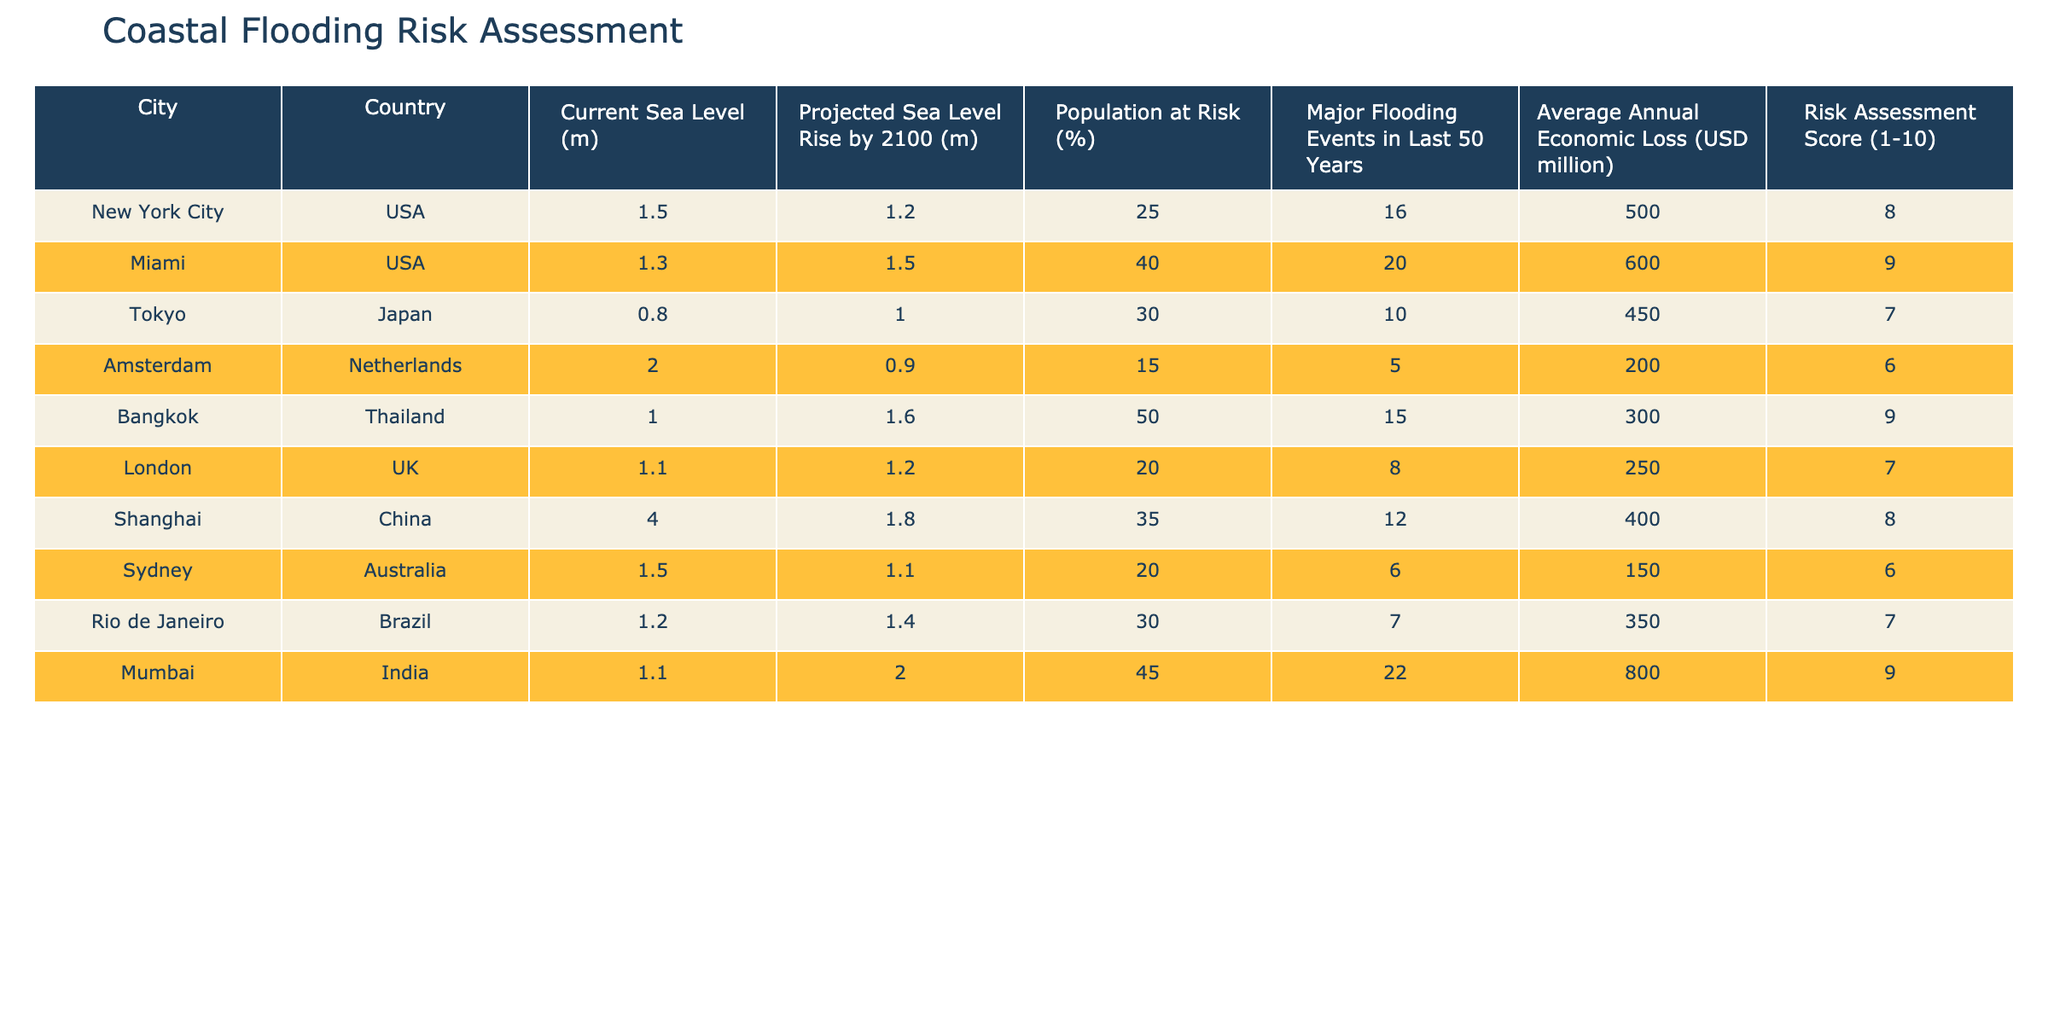What is the current sea level of Miami? The table lists the current sea level for Miami as 1.3 meters under the "Current Sea Level (m)" column.
Answer: 1.3 m Which city has the highest risk assessment score? By reviewing the "Risk Assessment Score (1-10)" column, Miami has the highest score of 9, indicating the greatest risk among the listed cities.
Answer: Miami (9) How many major flooding events has New York City experienced in the last 50 years? According to the "Major Flooding Events in Last 50 Years" column, New York City has experienced 16 major flooding events.
Answer: 16 What is the average annual economic loss for all cities combined? To find the average, sum the economic losses: (500 + 600 + 450 + 200 + 300 + 250 + 400 + 150 + 350 + 800) = 4150 million dollars. There are 10 cities, so the average is 4150 / 10 = 415 million dollars.
Answer: 415 million USD Is the projected sea level rise for London greater than that for Amsterdam? Comparing the projected sea level rises from the table, London is at 1.2 meters while Amsterdam is at 0.9 meters; thus, London has a greater projected rise.
Answer: Yes Which city has the highest percentage of population at risk? From the "Population at Risk (%)" column, Bangkok has the highest percentage at 50%.
Answer: Bangkok (50%) What is the difference in average annual economic loss between Mumbai and Sydney? Mumbai's loss is 800 million USD and Sydney's is 150 million USD. The difference is 800 - 150 = 650 million USD.
Answer: 650 million USD Which cities have a risk assessment score of 7 or higher? A quick scan reveals New York City, Miami, Shanghai, and Mumbai having scores of 8 or 9, while Tokyo and London score 7. Thus, the cities with scores 7 or higher are: New York City, Miami, Tokyo, London, Shanghai, and Mumbai.
Answer: New York City, Miami, Tokyo, London, Shanghai, Mumbai Is it true that Amsterdam has the lowest population at risk percentage? Upon checking the "Population at Risk (%)" column, Amsterdam has 15%, which is indeed the lowest figure listed compared to the others.
Answer: Yes 